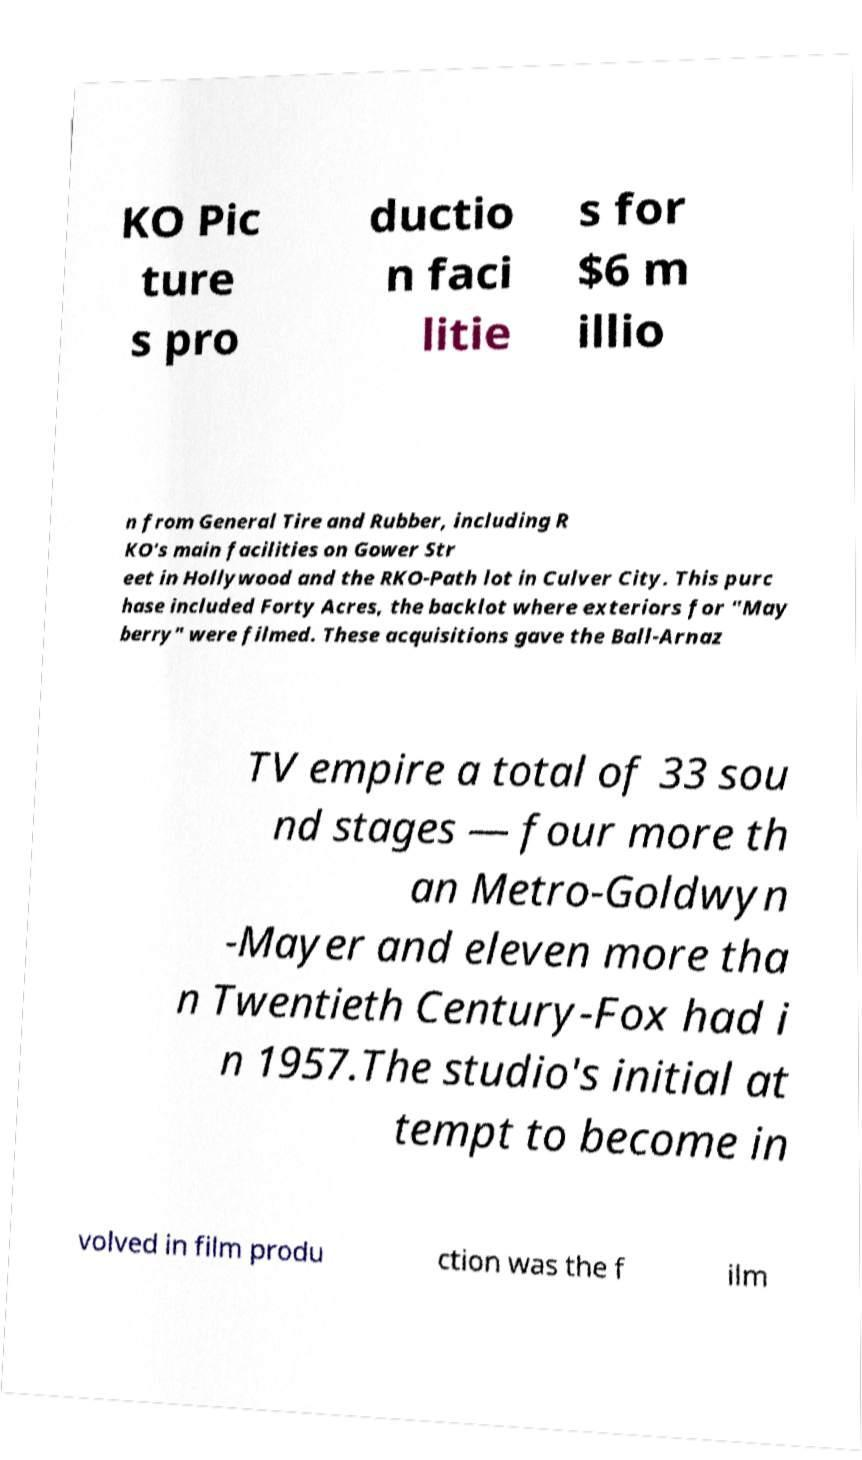What messages or text are displayed in this image? I need them in a readable, typed format. KO Pic ture s pro ductio n faci litie s for $6 m illio n from General Tire and Rubber, including R KO's main facilities on Gower Str eet in Hollywood and the RKO-Path lot in Culver City. This purc hase included Forty Acres, the backlot where exteriors for "May berry" were filmed. These acquisitions gave the Ball-Arnaz TV empire a total of 33 sou nd stages — four more th an Metro-Goldwyn -Mayer and eleven more tha n Twentieth Century-Fox had i n 1957.The studio's initial at tempt to become in volved in film produ ction was the f ilm 